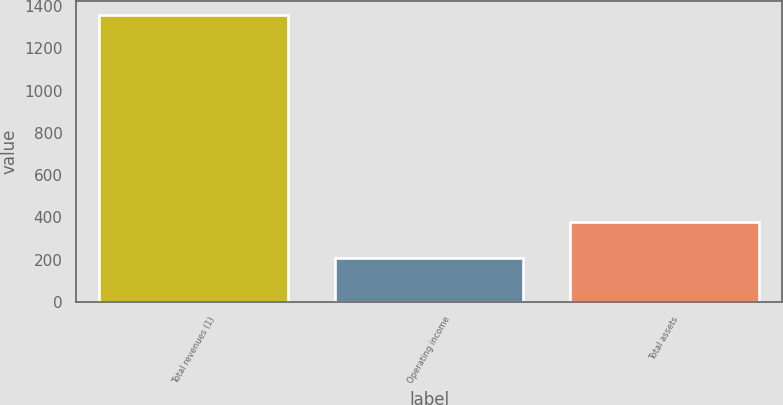<chart> <loc_0><loc_0><loc_500><loc_500><bar_chart><fcel>Total revenues (1)<fcel>Operating income<fcel>Total assets<nl><fcel>1356<fcel>208<fcel>379<nl></chart> 